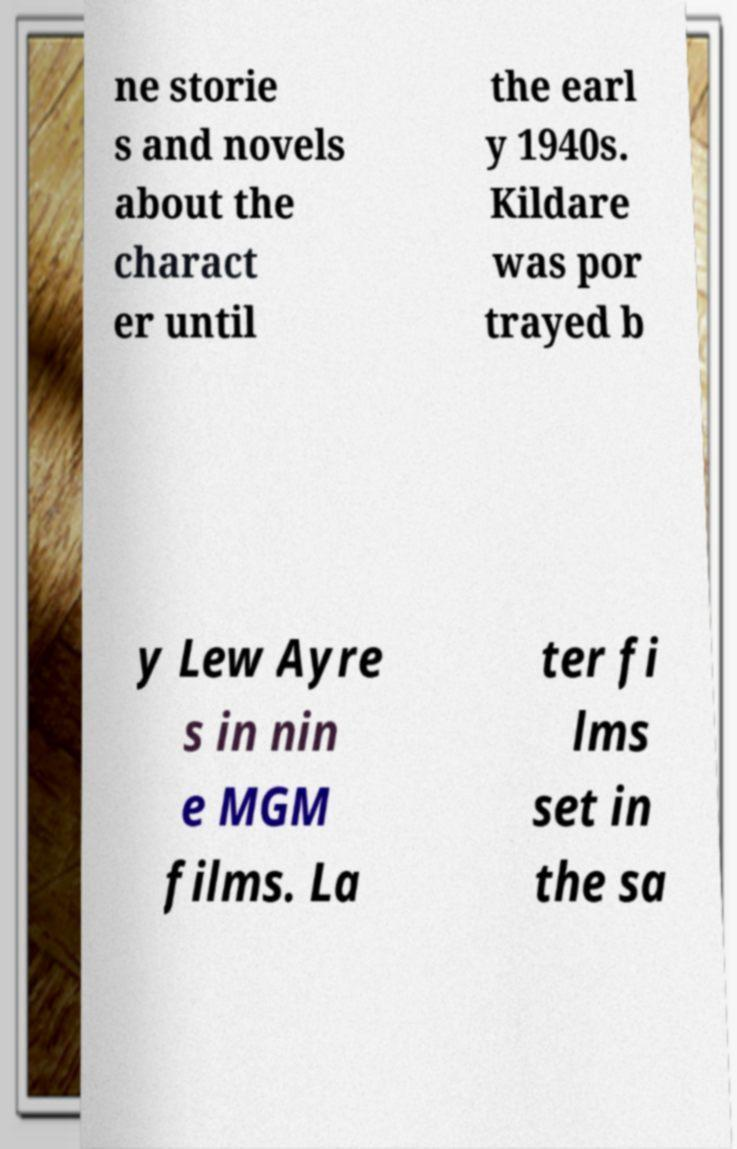Can you read and provide the text displayed in the image?This photo seems to have some interesting text. Can you extract and type it out for me? ne storie s and novels about the charact er until the earl y 1940s. Kildare was por trayed b y Lew Ayre s in nin e MGM films. La ter fi lms set in the sa 